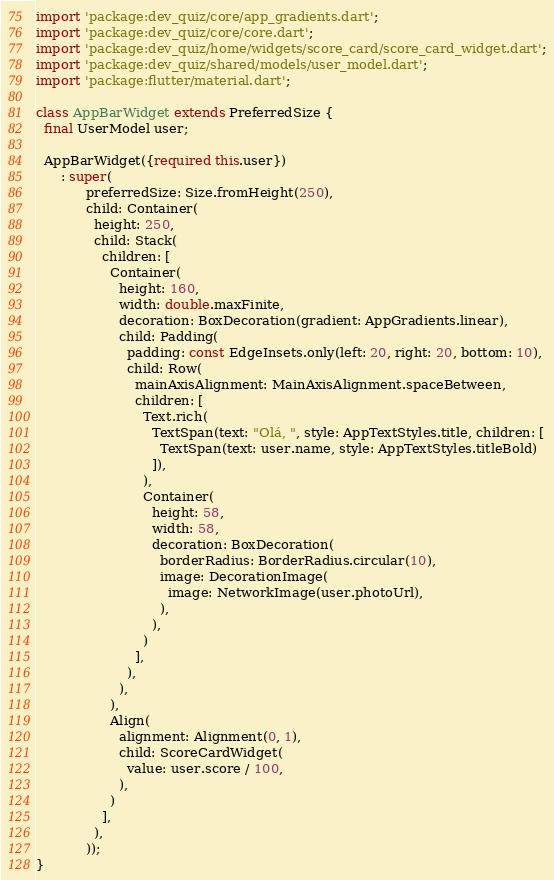Convert code to text. <code><loc_0><loc_0><loc_500><loc_500><_Dart_>import 'package:dev_quiz/core/app_gradients.dart';
import 'package:dev_quiz/core/core.dart';
import 'package:dev_quiz/home/widgets/score_card/score_card_widget.dart';
import 'package:dev_quiz/shared/models/user_model.dart';
import 'package:flutter/material.dart';

class AppBarWidget extends PreferredSize {
  final UserModel user;

  AppBarWidget({required this.user})
      : super(
            preferredSize: Size.fromHeight(250),
            child: Container(
              height: 250,
              child: Stack(
                children: [
                  Container(
                    height: 160,
                    width: double.maxFinite,
                    decoration: BoxDecoration(gradient: AppGradients.linear),
                    child: Padding(
                      padding: const EdgeInsets.only(left: 20, right: 20, bottom: 10),
                      child: Row(
                        mainAxisAlignment: MainAxisAlignment.spaceBetween,
                        children: [
                          Text.rich(
                            TextSpan(text: "Olá, ", style: AppTextStyles.title, children: [
                              TextSpan(text: user.name, style: AppTextStyles.titleBold)
                            ]),
                          ),
                          Container(
                            height: 58,
                            width: 58,
                            decoration: BoxDecoration(
                              borderRadius: BorderRadius.circular(10),
                              image: DecorationImage(
                                image: NetworkImage(user.photoUrl),
                              ),
                            ),
                          )
                        ],
                      ),
                    ),
                  ),
                  Align(
                    alignment: Alignment(0, 1),
                    child: ScoreCardWidget(
                      value: user.score / 100,
                    ),
                  )
                ],
              ),
            ));
}
</code> 